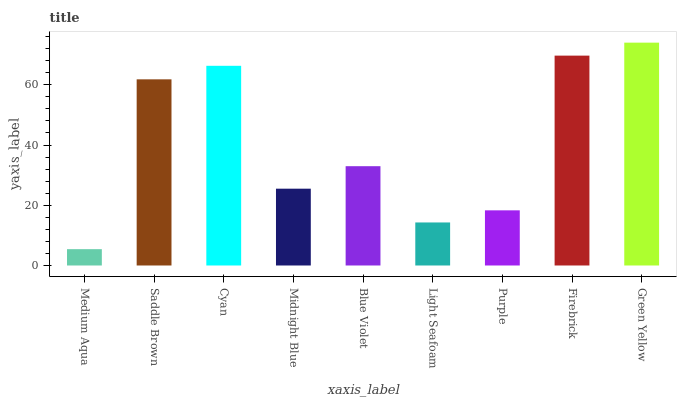Is Medium Aqua the minimum?
Answer yes or no. Yes. Is Green Yellow the maximum?
Answer yes or no. Yes. Is Saddle Brown the minimum?
Answer yes or no. No. Is Saddle Brown the maximum?
Answer yes or no. No. Is Saddle Brown greater than Medium Aqua?
Answer yes or no. Yes. Is Medium Aqua less than Saddle Brown?
Answer yes or no. Yes. Is Medium Aqua greater than Saddle Brown?
Answer yes or no. No. Is Saddle Brown less than Medium Aqua?
Answer yes or no. No. Is Blue Violet the high median?
Answer yes or no. Yes. Is Blue Violet the low median?
Answer yes or no. Yes. Is Firebrick the high median?
Answer yes or no. No. Is Light Seafoam the low median?
Answer yes or no. No. 